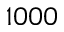<formula> <loc_0><loc_0><loc_500><loc_500>1 0 0 0</formula> 